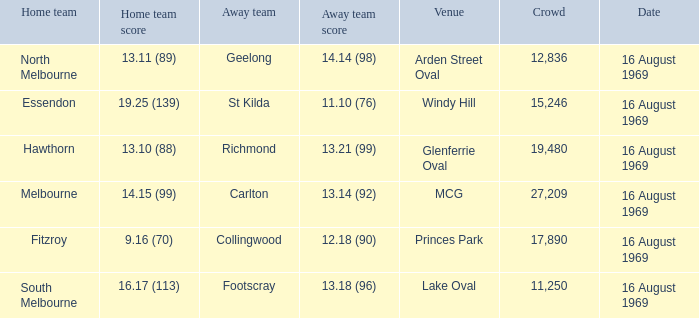Who was home at Princes Park? 9.16 (70). 